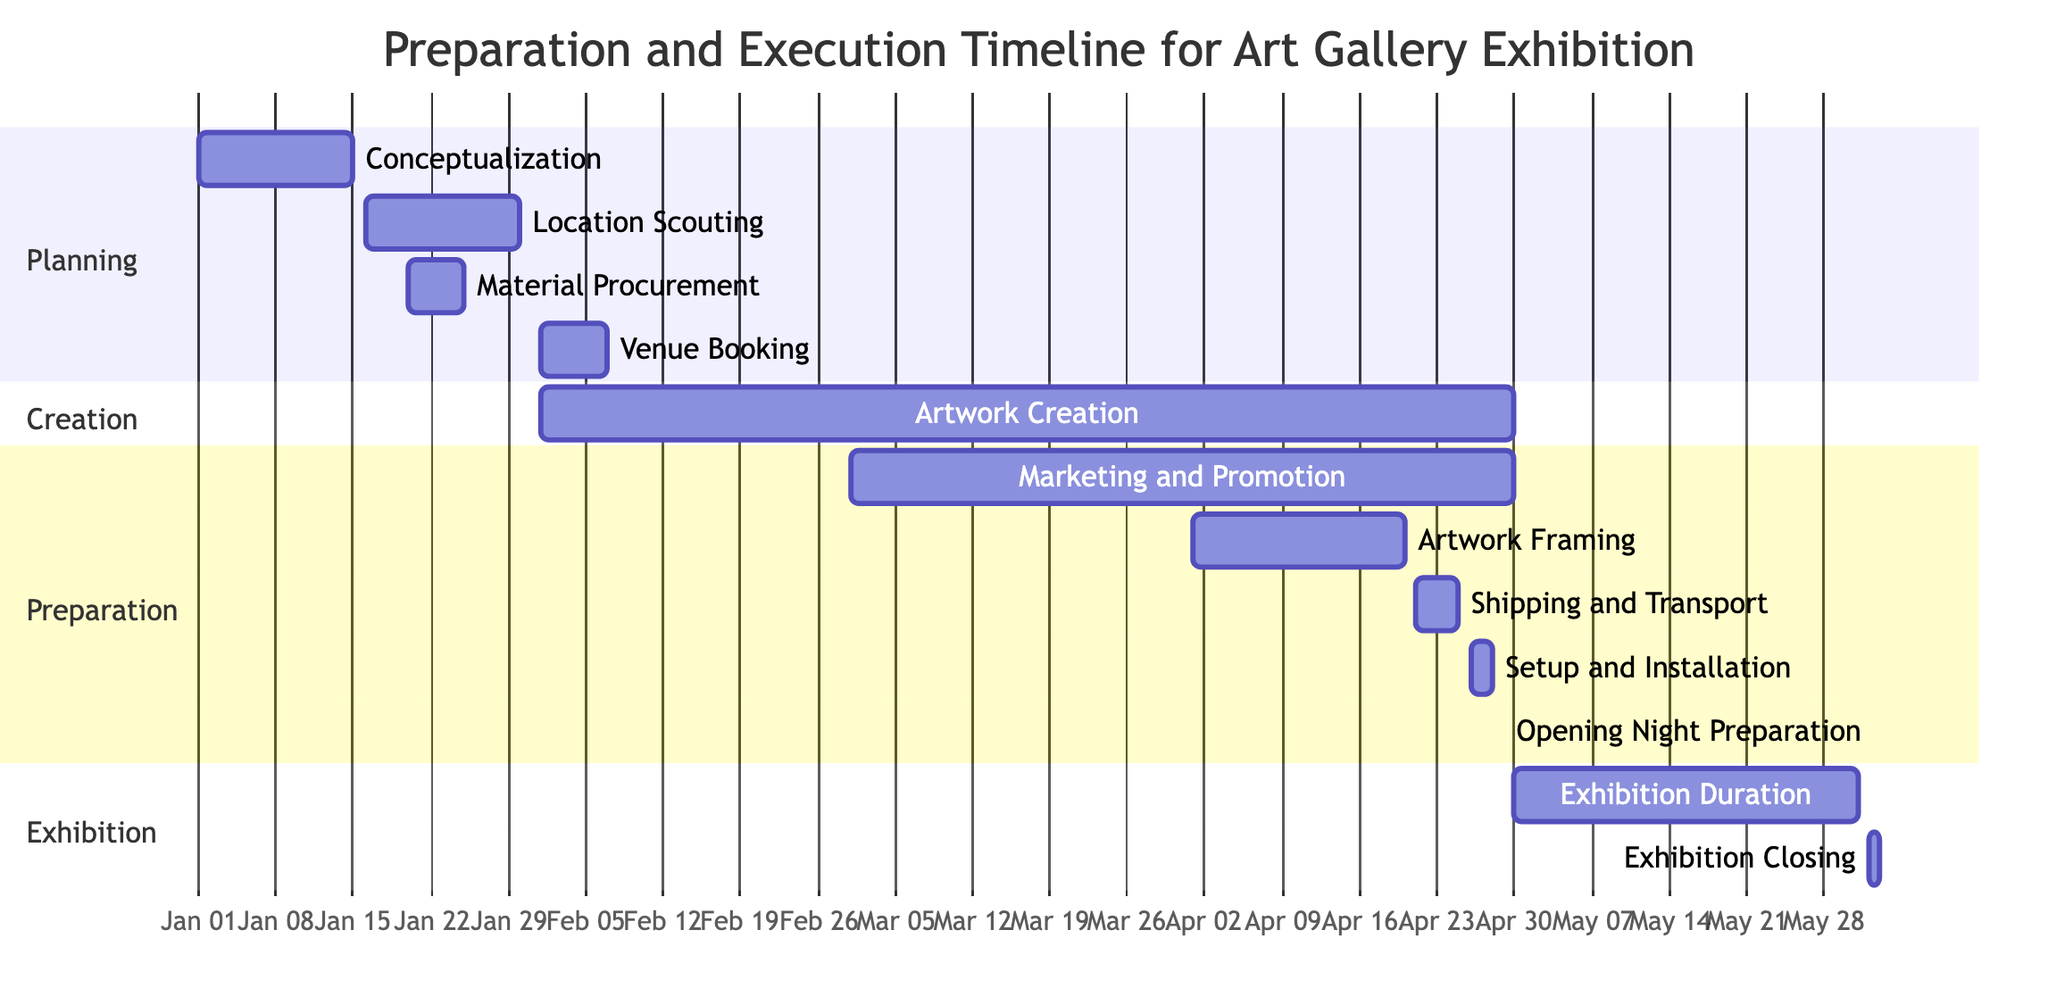What is the duration of the Artwork Creation task? The Artwork Creation task starts on February 1, 2023, and ends on April 30, 2023. Therefore, the duration is the difference between these two dates, which is 3 months.
Answer: 3 months Which task is scheduled to begin immediately after Material Procurement? Material Procurement ends on January 25, 2023. The next task, Location Scouting, starts on January 16, 2023, which is before Material Procurement ends. Therefore, to find the next task after it finishes, we look for what comes after January 25. The task that starts after is Venue Booking.
Answer: Venue Booking How many tasks are scheduled in the Preparation section? The Preparation section includes Marketing and Promotion, Artwork Framing, Shipping and Transport, Setup and Installation, and Opening Night Preparation. Counting these, we find there are 5 tasks in total.
Answer: 5 tasks Which task overlaps with Artwork Creation? The task Marketing and Promotion starts on March 1, 2023, and ends on April 30, 2023, which overlaps entirely with the Artwork Creation task that runs from February 1 to April 30.
Answer: Marketing and Promotion What is the start date of the Exhibition Duration? The Exhibition Duration task starts on April 30, 2023, as indicated in the diagram.
Answer: April 30, 2023 Which task has the shortest duration? Opening Night Preparation is a single-day task that occurs on April 29, 2023. Since it only lasts one day compared to the other tasks, it has the shortest duration.
Answer: Opening Night Preparation During which week is the Setup and Installation scheduled? The Setup and Installation task runs from April 26 to April 28, 2023. This falls within the week that starts on April 24, 2023.
Answer: April 24, 2023 What is the total duration of the entire exhibition process from start to finish? The entire exhibition process starts with Conceptualization on January 1, 2023, and concludes with Exhibition Closing on June 2, 2023. Thus, the total duration is from January 1 to June 2, which is 5 months and 1 day.
Answer: 5 months and 1 day 